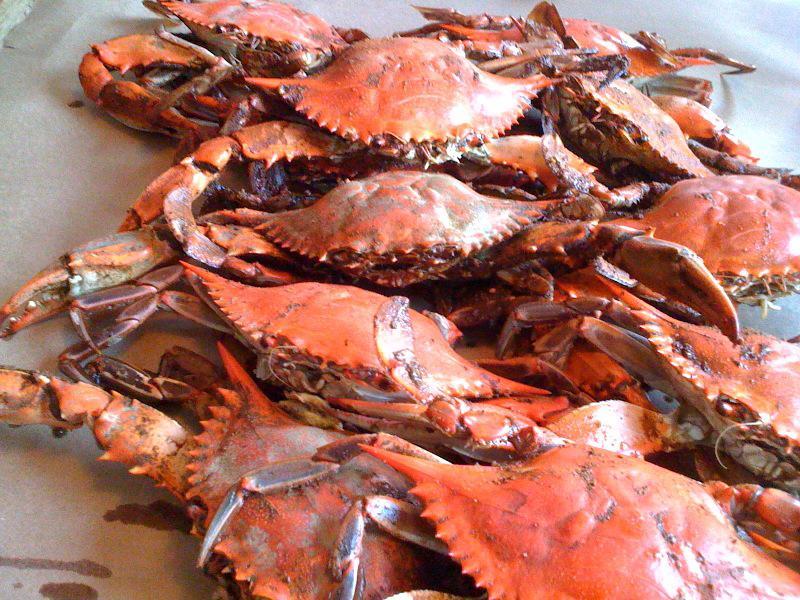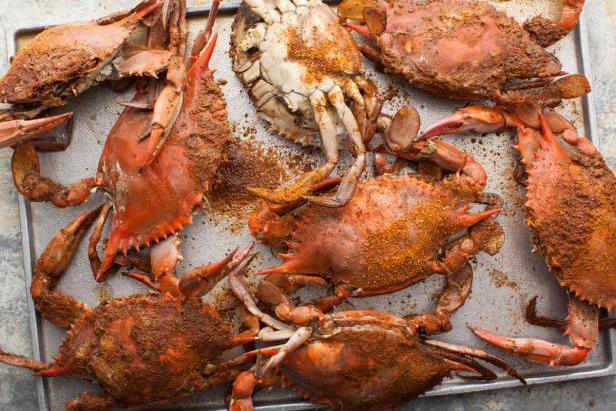The first image is the image on the left, the second image is the image on the right. Given the left and right images, does the statement "The left image shows a pile of forward-facing reddish-orange shell-side up crabs without distinctive spots or a visible container." hold true? Answer yes or no. Yes. The first image is the image on the left, the second image is the image on the right. Evaluate the accuracy of this statement regarding the images: "At least one of the pictures shows crabs being carried in a round bucket.". Is it true? Answer yes or no. No. 